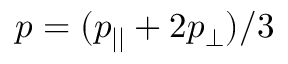Convert formula to latex. <formula><loc_0><loc_0><loc_500><loc_500>p = ( p _ { | | } + 2 p _ { \perp } ) / 3</formula> 